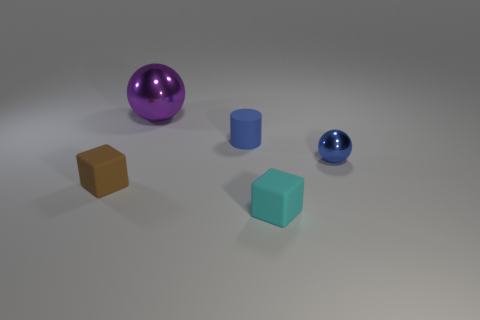The tiny rubber object behind the small shiny sphere is what color?
Give a very brief answer. Blue. There is a rubber cube that is to the left of the big purple metal object; is there a tiny rubber object to the right of it?
Keep it short and to the point. Yes. There is a tiny shiny object; does it have the same color as the matte object that is behind the blue metallic sphere?
Provide a succinct answer. Yes. Is there a tiny blue object made of the same material as the tiny cyan object?
Keep it short and to the point. Yes. How many tiny yellow objects are there?
Give a very brief answer. 0. There is a ball that is behind the shiny sphere to the right of the purple object; what is it made of?
Offer a terse response. Metal. What color is the other thing that is made of the same material as the big purple object?
Make the answer very short. Blue. What shape is the object that is the same color as the cylinder?
Your answer should be compact. Sphere. There is a matte block that is right of the small brown block; does it have the same size as the block left of the matte cylinder?
Keep it short and to the point. Yes. How many spheres are tiny blue matte things or big metal things?
Make the answer very short. 1. 